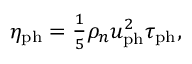Convert formula to latex. <formula><loc_0><loc_0><loc_500><loc_500>\begin{array} { r } { \eta _ { p h } = \frac { 1 } { 5 } \rho _ { n } u _ { p h } ^ { 2 } \tau _ { p h } , } \end{array}</formula> 